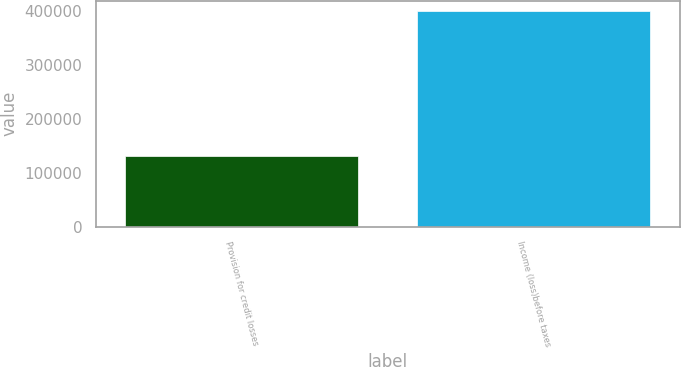Convert chart to OTSL. <chart><loc_0><loc_0><loc_500><loc_500><bar_chart><fcel>Provision for credit losses<fcel>Income (loss)before taxes<nl><fcel>130509<fcel>400219<nl></chart> 